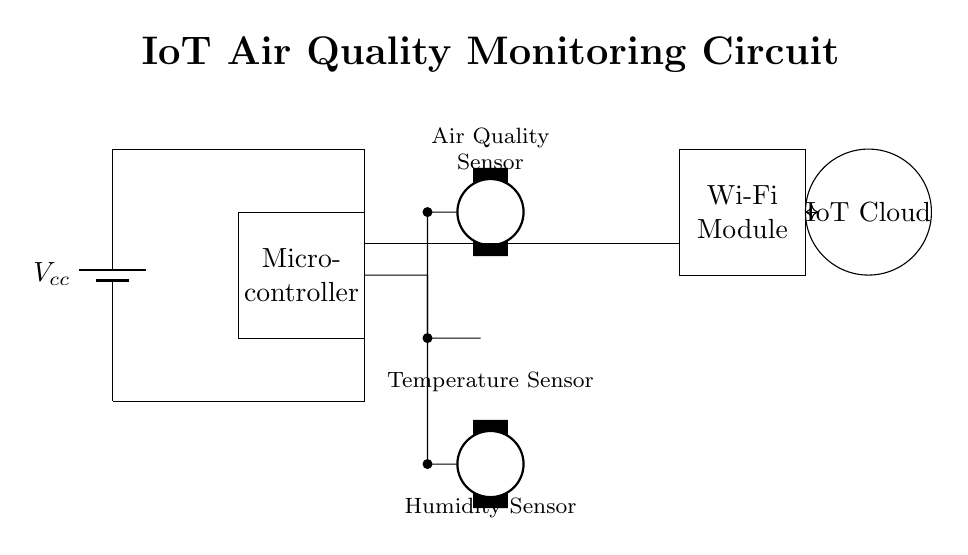What is the main power supply of this circuit? The main power supply is represented by a battery symbol labeled with Vcc. It provides the necessary voltage for operation.
Answer: Vcc What components are used to measure environmental conditions? The circuit includes air quality, temperature, and humidity sensors, which are specifically designed to monitor these environmental conditions.
Answer: Air quality sensor, temperature sensor, humidity sensor How does data from the sensors get sent to the IoT cloud? The microcontroller processes the sensor data and communicates it through the Wi-Fi module, which sends the information to the IoT Cloud for further analysis.
Answer: Wi-Fi module What is the function of the microcontroller in this circuit? The microcontroller serves as the central processing unit that receives input from the sensors, processes the data, and drives communication to external systems like the Wi-Fi module.
Answer: Central processing unit Which component connects the sensors to the microcontroller? The wires or short connections (indicated by short lines) serve as pathways that connect the sensors to the microcontroller, allowing for data transfer between these elements.
Answer: Short connections What type of circuit is this? This circuit is an Internet of Things (IoT) sensor circuit designed for environmental monitoring.
Answer: IoT sensor circuit 